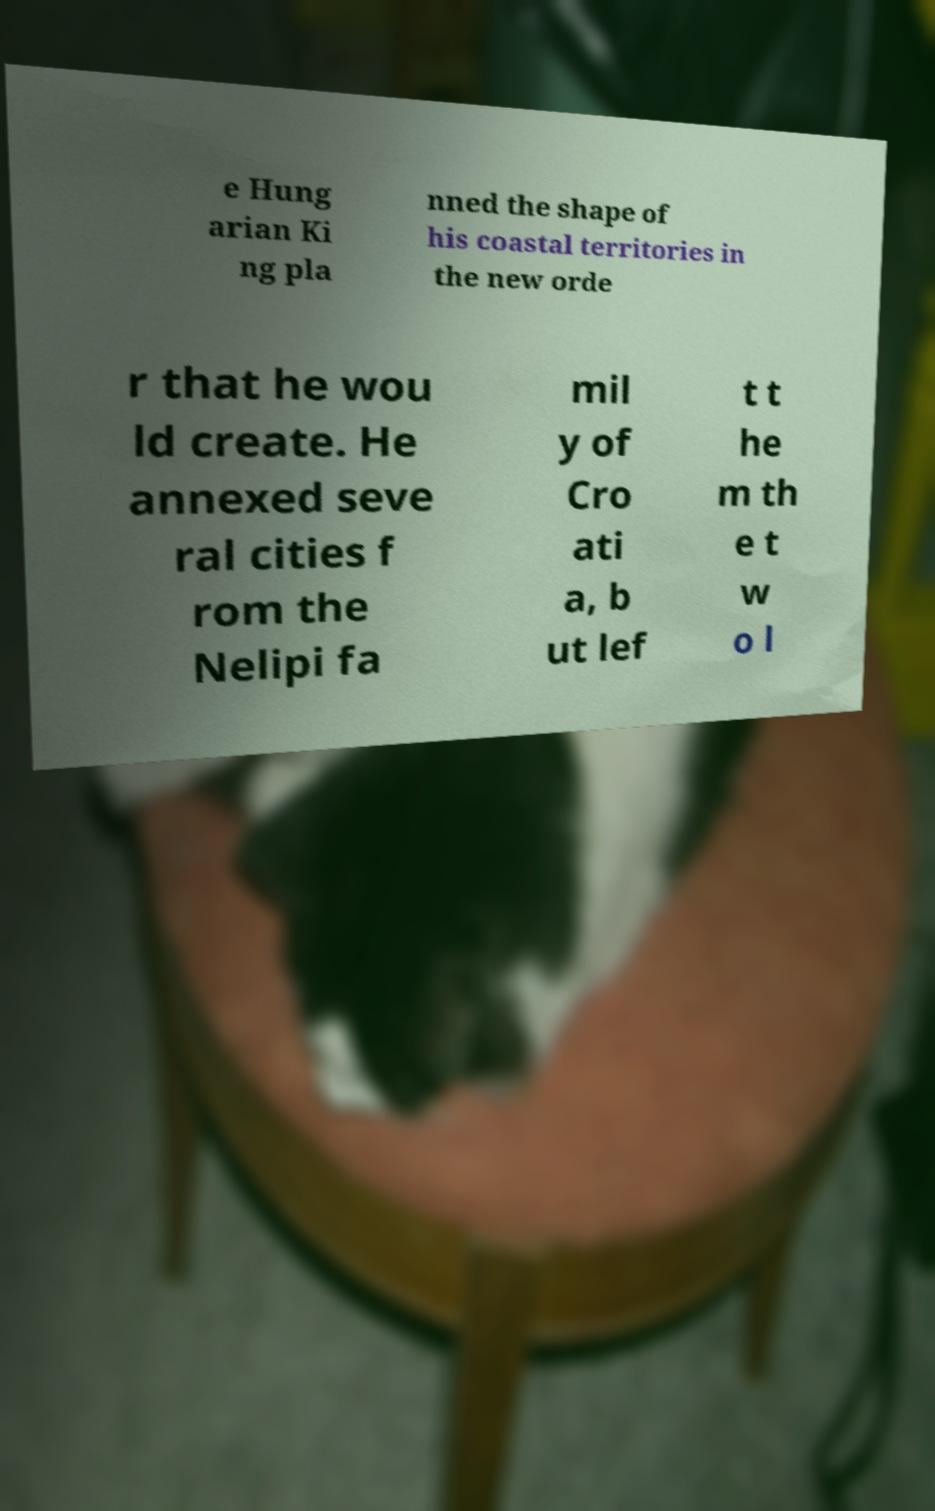Please identify and transcribe the text found in this image. e Hung arian Ki ng pla nned the shape of his coastal territories in the new orde r that he wou ld create. He annexed seve ral cities f rom the Nelipi fa mil y of Cro ati a, b ut lef t t he m th e t w o l 